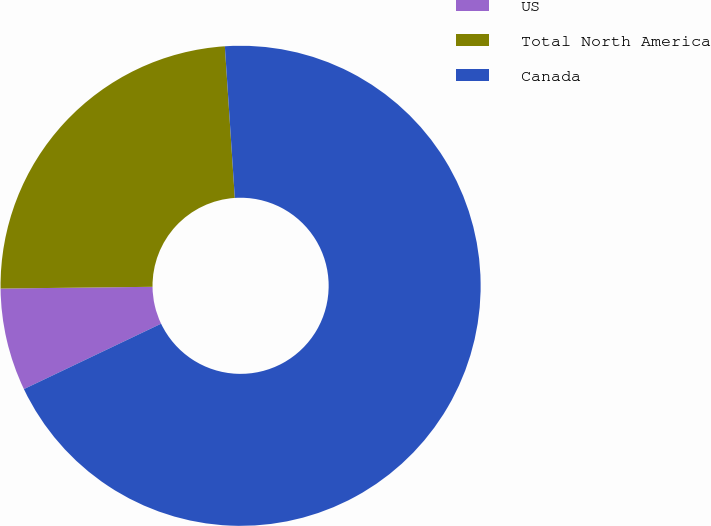Convert chart. <chart><loc_0><loc_0><loc_500><loc_500><pie_chart><fcel>US<fcel>Total North America<fcel>Canada<nl><fcel>6.9%<fcel>24.14%<fcel>68.97%<nl></chart> 